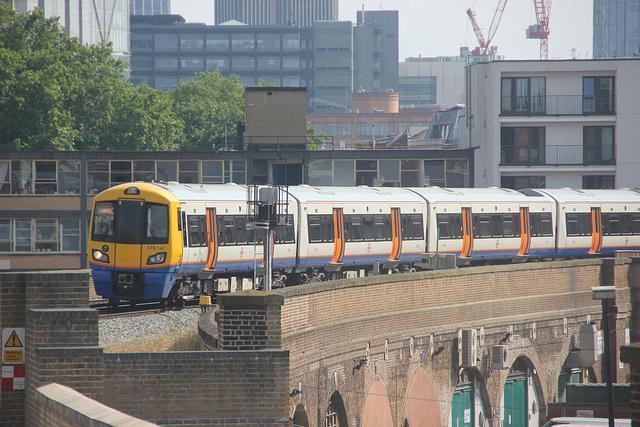How many light on the front of the train are lit?
Give a very brief answer. 1. 